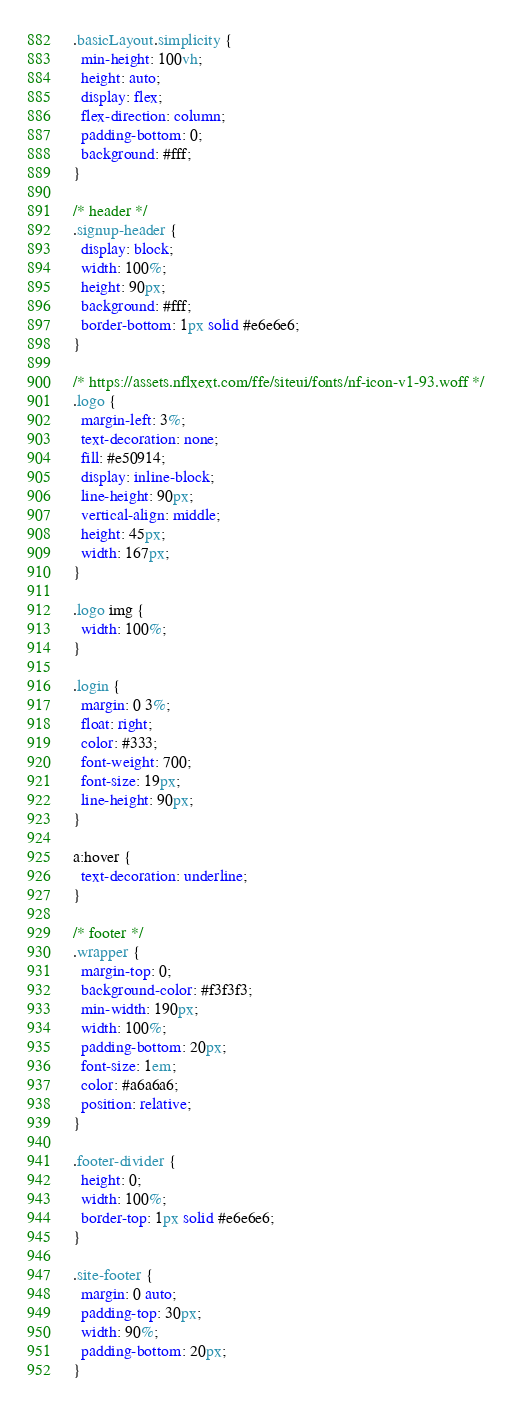Convert code to text. <code><loc_0><loc_0><loc_500><loc_500><_CSS_>.basicLayout.simplicity {
  min-height: 100vh;
  height: auto;
  display: flex;
  flex-direction: column;
  padding-bottom: 0;
  background: #fff;
}

/* header */
.signup-header {
  display: block;
  width: 100%;
  height: 90px;
  background: #fff;
  border-bottom: 1px solid #e6e6e6;
}

/* https://assets.nflxext.com/ffe/siteui/fonts/nf-icon-v1-93.woff */
.logo {
  margin-left: 3%;
  text-decoration: none;
  fill: #e50914;
  display: inline-block;
  line-height: 90px;
  vertical-align: middle;
  height: 45px;
  width: 167px;
}

.logo img {
  width: 100%;
}

.login {
  margin: 0 3%;
  float: right;
  color: #333;
  font-weight: 700;
  font-size: 19px;
  line-height: 90px;
}

a:hover {
  text-decoration: underline;
}

/* footer */
.wrapper {
  margin-top: 0;
  background-color: #f3f3f3;
  min-width: 190px;
  width: 100%;
  padding-bottom: 20px;
  font-size: 1em;
  color: #a6a6a6;
  position: relative;
}

.footer-divider {
  height: 0;
  width: 100%;
  border-top: 1px solid #e6e6e6;
}

.site-footer {
  margin: 0 auto;
  padding-top: 30px;
  width: 90%;
  padding-bottom: 20px;
}
</code> 